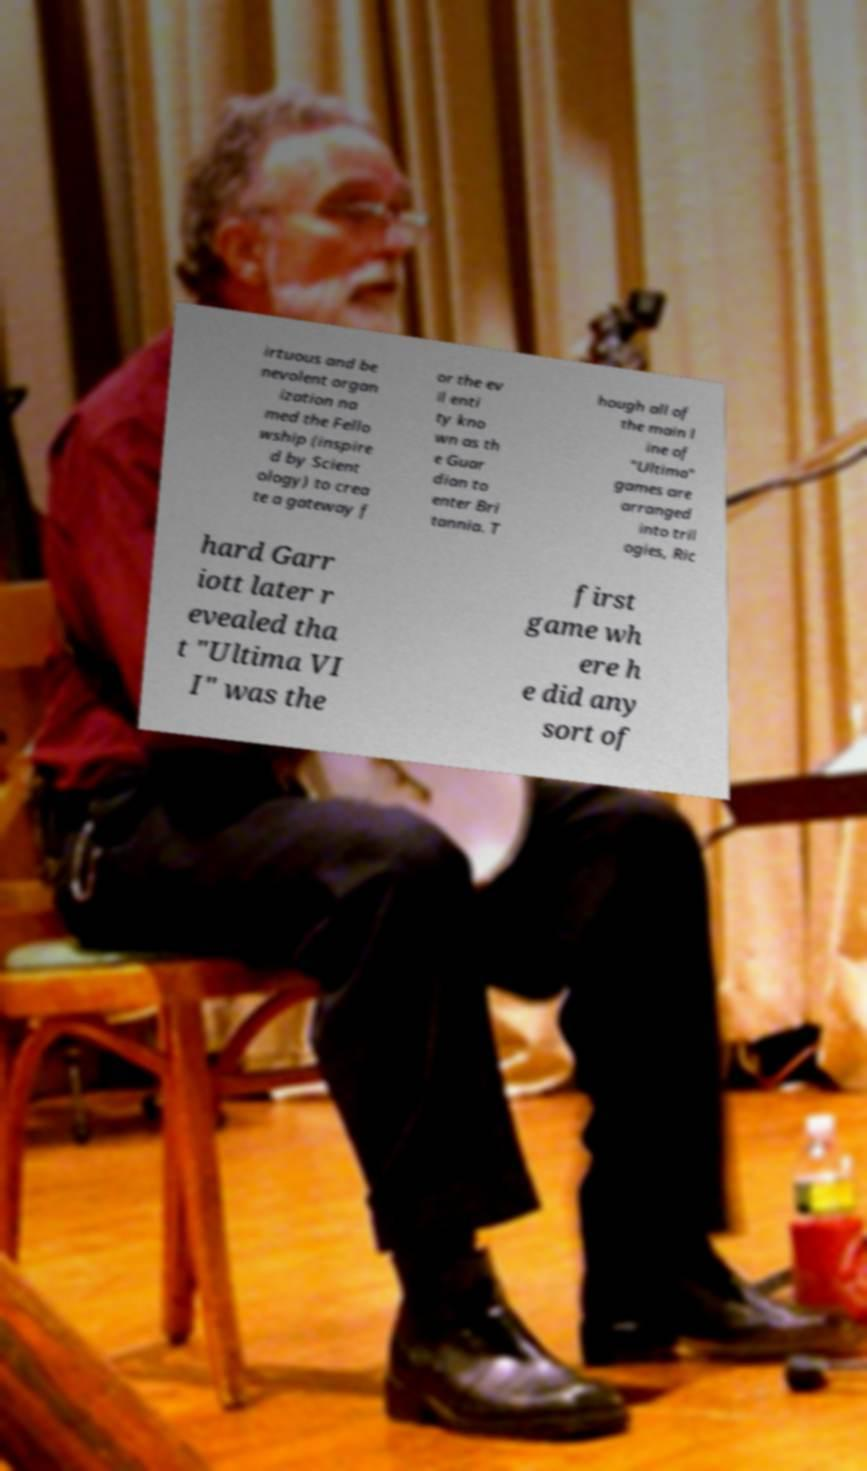Could you extract and type out the text from this image? irtuous and be nevolent organ ization na med the Fello wship (inspire d by Scient ology) to crea te a gateway f or the ev il enti ty kno wn as th e Guar dian to enter Bri tannia. T hough all of the main l ine of "Ultima" games are arranged into tril ogies, Ric hard Garr iott later r evealed tha t "Ultima VI I" was the first game wh ere h e did any sort of 